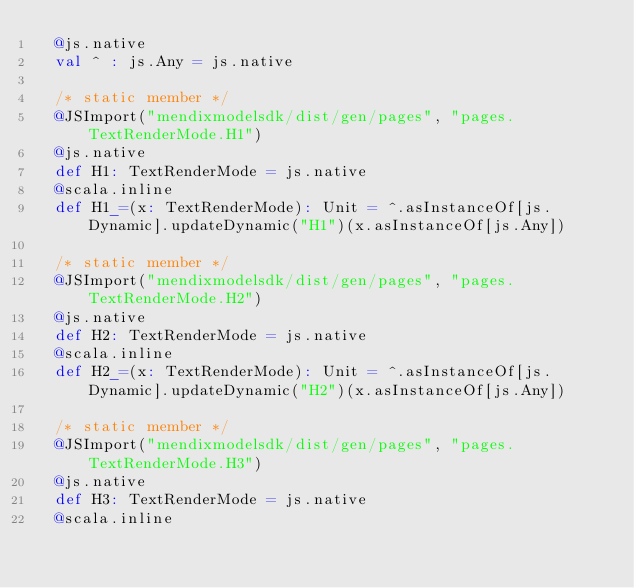Convert code to text. <code><loc_0><loc_0><loc_500><loc_500><_Scala_>  @js.native
  val ^ : js.Any = js.native
  
  /* static member */
  @JSImport("mendixmodelsdk/dist/gen/pages", "pages.TextRenderMode.H1")
  @js.native
  def H1: TextRenderMode = js.native
  @scala.inline
  def H1_=(x: TextRenderMode): Unit = ^.asInstanceOf[js.Dynamic].updateDynamic("H1")(x.asInstanceOf[js.Any])
  
  /* static member */
  @JSImport("mendixmodelsdk/dist/gen/pages", "pages.TextRenderMode.H2")
  @js.native
  def H2: TextRenderMode = js.native
  @scala.inline
  def H2_=(x: TextRenderMode): Unit = ^.asInstanceOf[js.Dynamic].updateDynamic("H2")(x.asInstanceOf[js.Any])
  
  /* static member */
  @JSImport("mendixmodelsdk/dist/gen/pages", "pages.TextRenderMode.H3")
  @js.native
  def H3: TextRenderMode = js.native
  @scala.inline</code> 